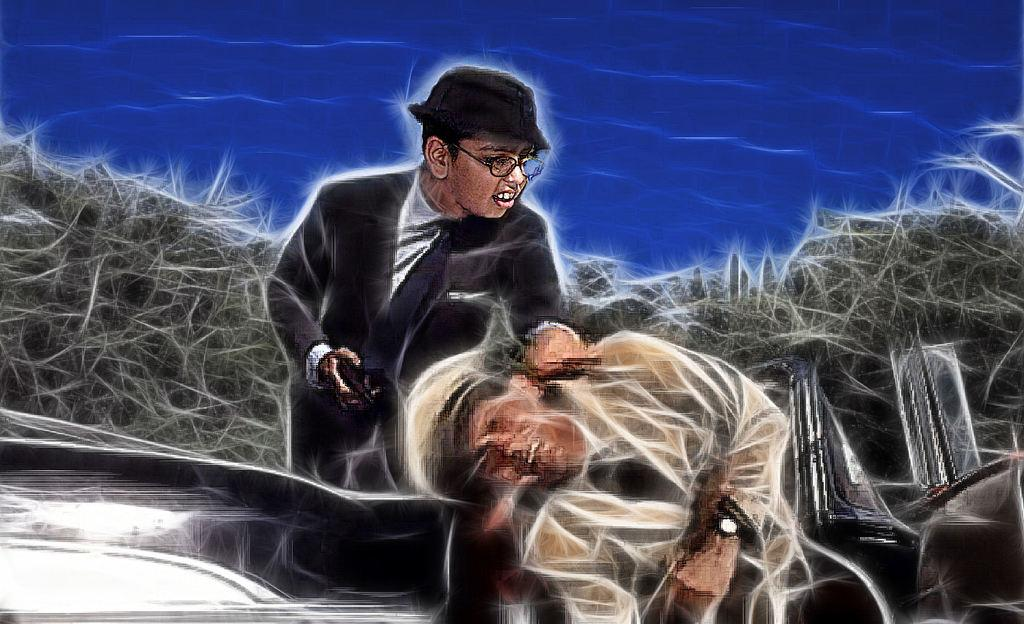What type of image is being described? The image is animated. What can be seen in the image? There are people and objects in the image. What color is the background of the image? The background of the image is blue. Where is the faucet located in the image? There is no faucet present in the image. What type of observation can be made about the engine in the image? There is no engine present in the image. 